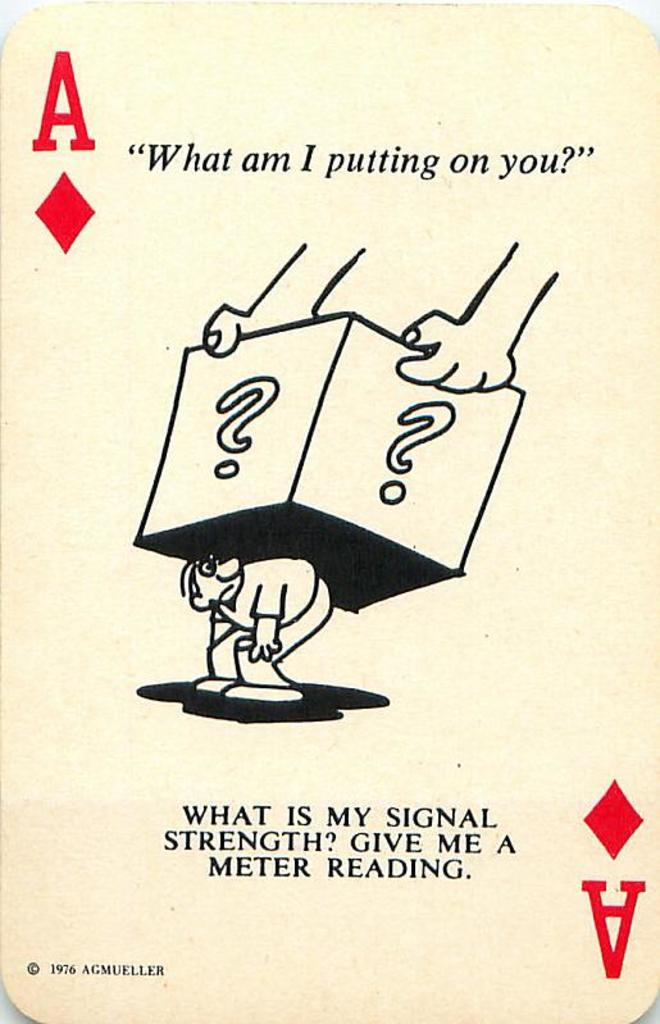Provide a one-sentence caption for the provided image. A playing card asking "What am I putting on you?". 